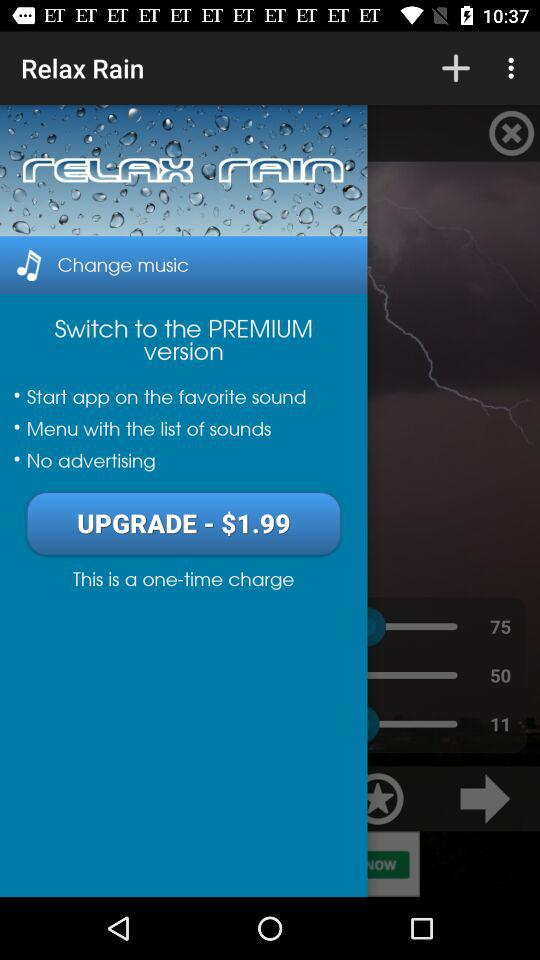What is the upgrade cost? The upgrade cost is $1.99. 